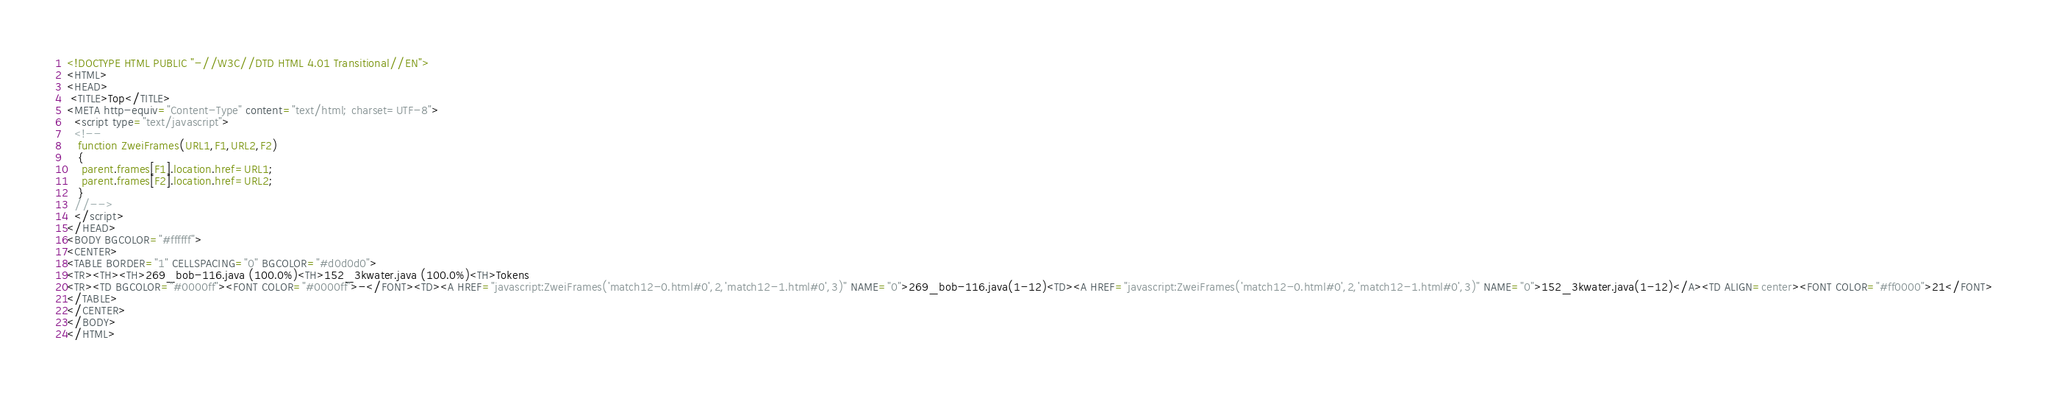<code> <loc_0><loc_0><loc_500><loc_500><_HTML_><!DOCTYPE HTML PUBLIC "-//W3C//DTD HTML 4.01 Transitional//EN">
<HTML>
<HEAD>
 <TITLE>Top</TITLE>
<META http-equiv="Content-Type" content="text/html; charset=UTF-8">
  <script type="text/javascript">
  <!--
   function ZweiFrames(URL1,F1,URL2,F2)
   {
    parent.frames[F1].location.href=URL1;
    parent.frames[F2].location.href=URL2;
   }
  //-->
  </script>
</HEAD>
<BODY BGCOLOR="#ffffff">
<CENTER>
<TABLE BORDER="1" CELLSPACING="0" BGCOLOR="#d0d0d0">
<TR><TH><TH>269_bob-116.java (100.0%)<TH>152_3kwater.java (100.0%)<TH>Tokens
<TR><TD BGCOLOR="#0000ff"><FONT COLOR="#0000ff">-</FONT><TD><A HREF="javascript:ZweiFrames('match12-0.html#0',2,'match12-1.html#0',3)" NAME="0">269_bob-116.java(1-12)<TD><A HREF="javascript:ZweiFrames('match12-0.html#0',2,'match12-1.html#0',3)" NAME="0">152_3kwater.java(1-12)</A><TD ALIGN=center><FONT COLOR="#ff0000">21</FONT>
</TABLE>
</CENTER>
</BODY>
</HTML>

</code> 